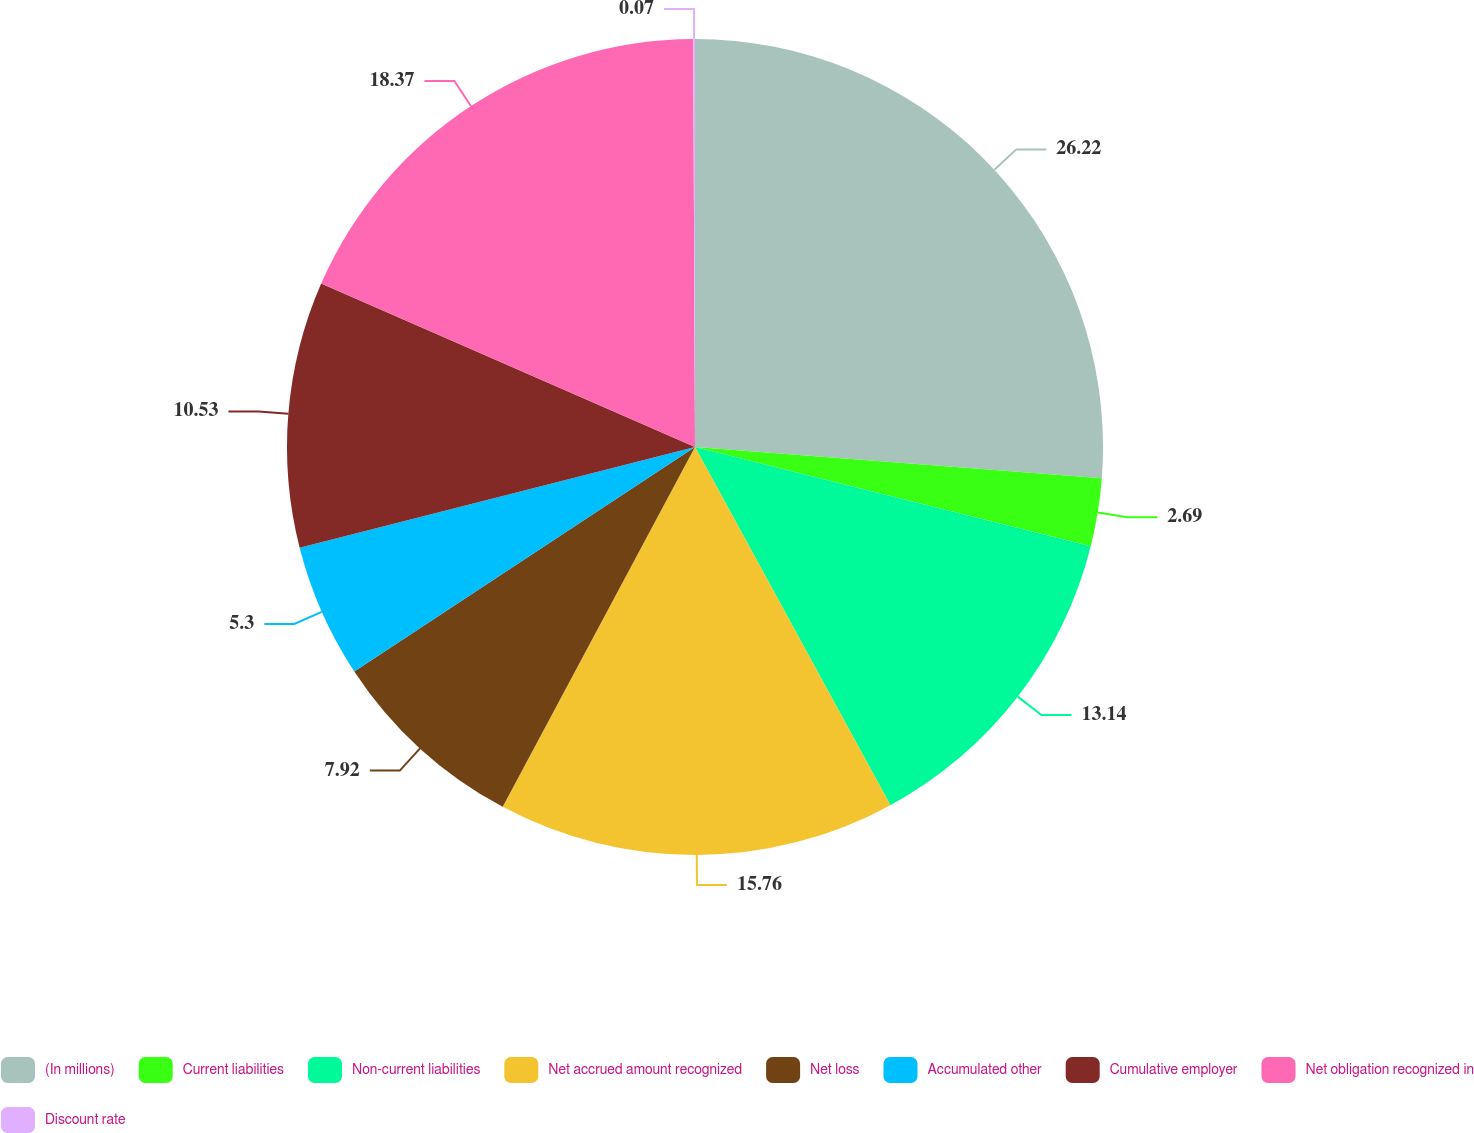Convert chart. <chart><loc_0><loc_0><loc_500><loc_500><pie_chart><fcel>(In millions)<fcel>Current liabilities<fcel>Non-current liabilities<fcel>Net accrued amount recognized<fcel>Net loss<fcel>Accumulated other<fcel>Cumulative employer<fcel>Net obligation recognized in<fcel>Discount rate<nl><fcel>26.22%<fcel>2.69%<fcel>13.14%<fcel>15.76%<fcel>7.92%<fcel>5.3%<fcel>10.53%<fcel>18.37%<fcel>0.07%<nl></chart> 